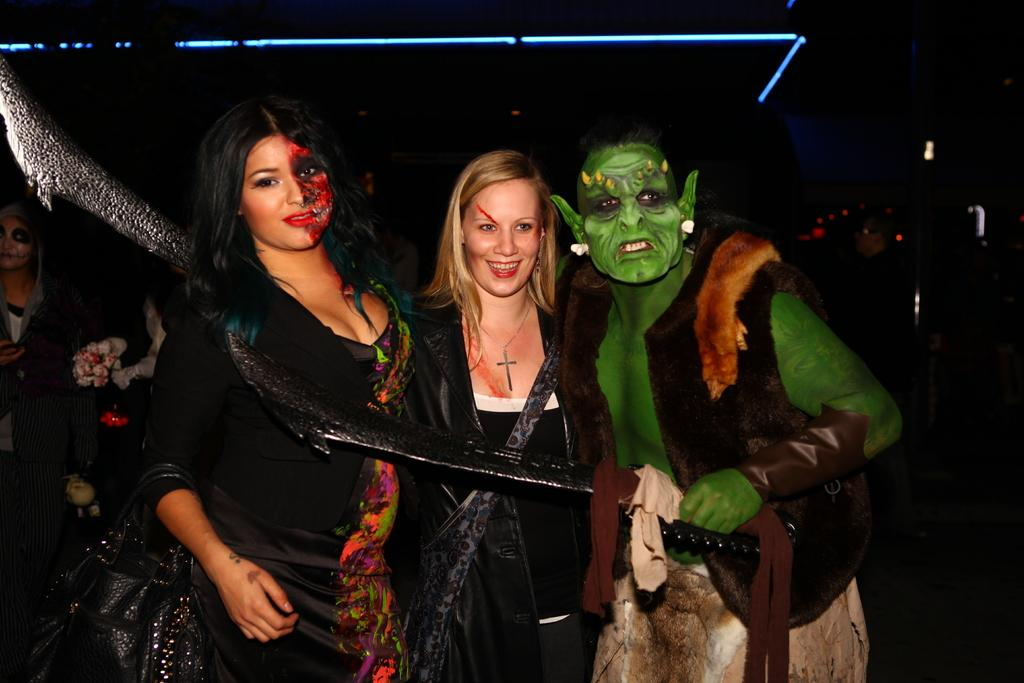What is happening in the image? There are people standing in the image. What is unique about the people's appearance? The people have paintings on their faces. What can be seen in the background of the image? There appears to be a tree in the background of the image. What type of texture can be seen on the church in the image? There is no church present in the image; it features people with painted faces and a tree in the background. 